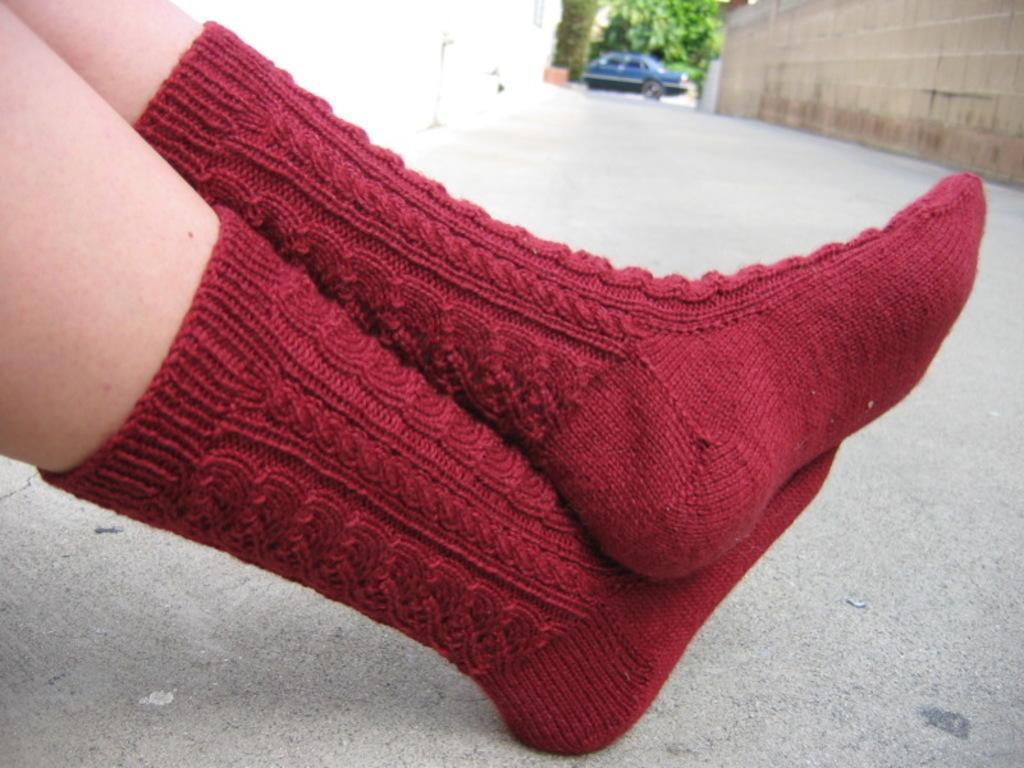Can you describe this image briefly? We can see a person's leg with red socks. There is a road. In the background we can see wall, car and tree. 